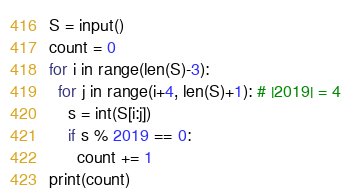Convert code to text. <code><loc_0><loc_0><loc_500><loc_500><_Python_>S = input()
count = 0
for i in range(len(S)-3):
  for j in range(i+4, len(S)+1): # |2019| = 4
    s = int(S[i:j])
    if s % 2019 == 0:
      count += 1
print(count)</code> 